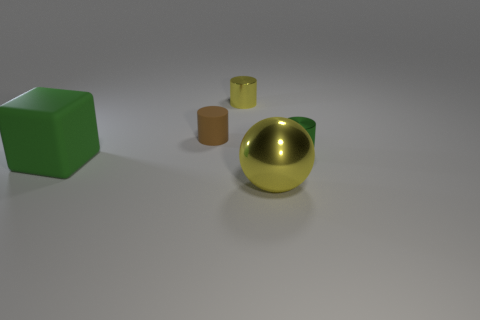Add 3 small gray cylinders. How many objects exist? 8 Subtract all blocks. How many objects are left? 4 Add 2 brown rubber things. How many brown rubber things are left? 3 Add 2 red matte things. How many red matte things exist? 2 Subtract 0 blue cubes. How many objects are left? 5 Subtract all large brown matte things. Subtract all large matte blocks. How many objects are left? 4 